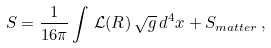Convert formula to latex. <formula><loc_0><loc_0><loc_500><loc_500>S = \frac { 1 } { 1 6 \pi } \int \, \mathcal { L } ( R ) \, \sqrt { g } \, d ^ { 4 } x + S _ { m a t t e r } \, ,</formula> 